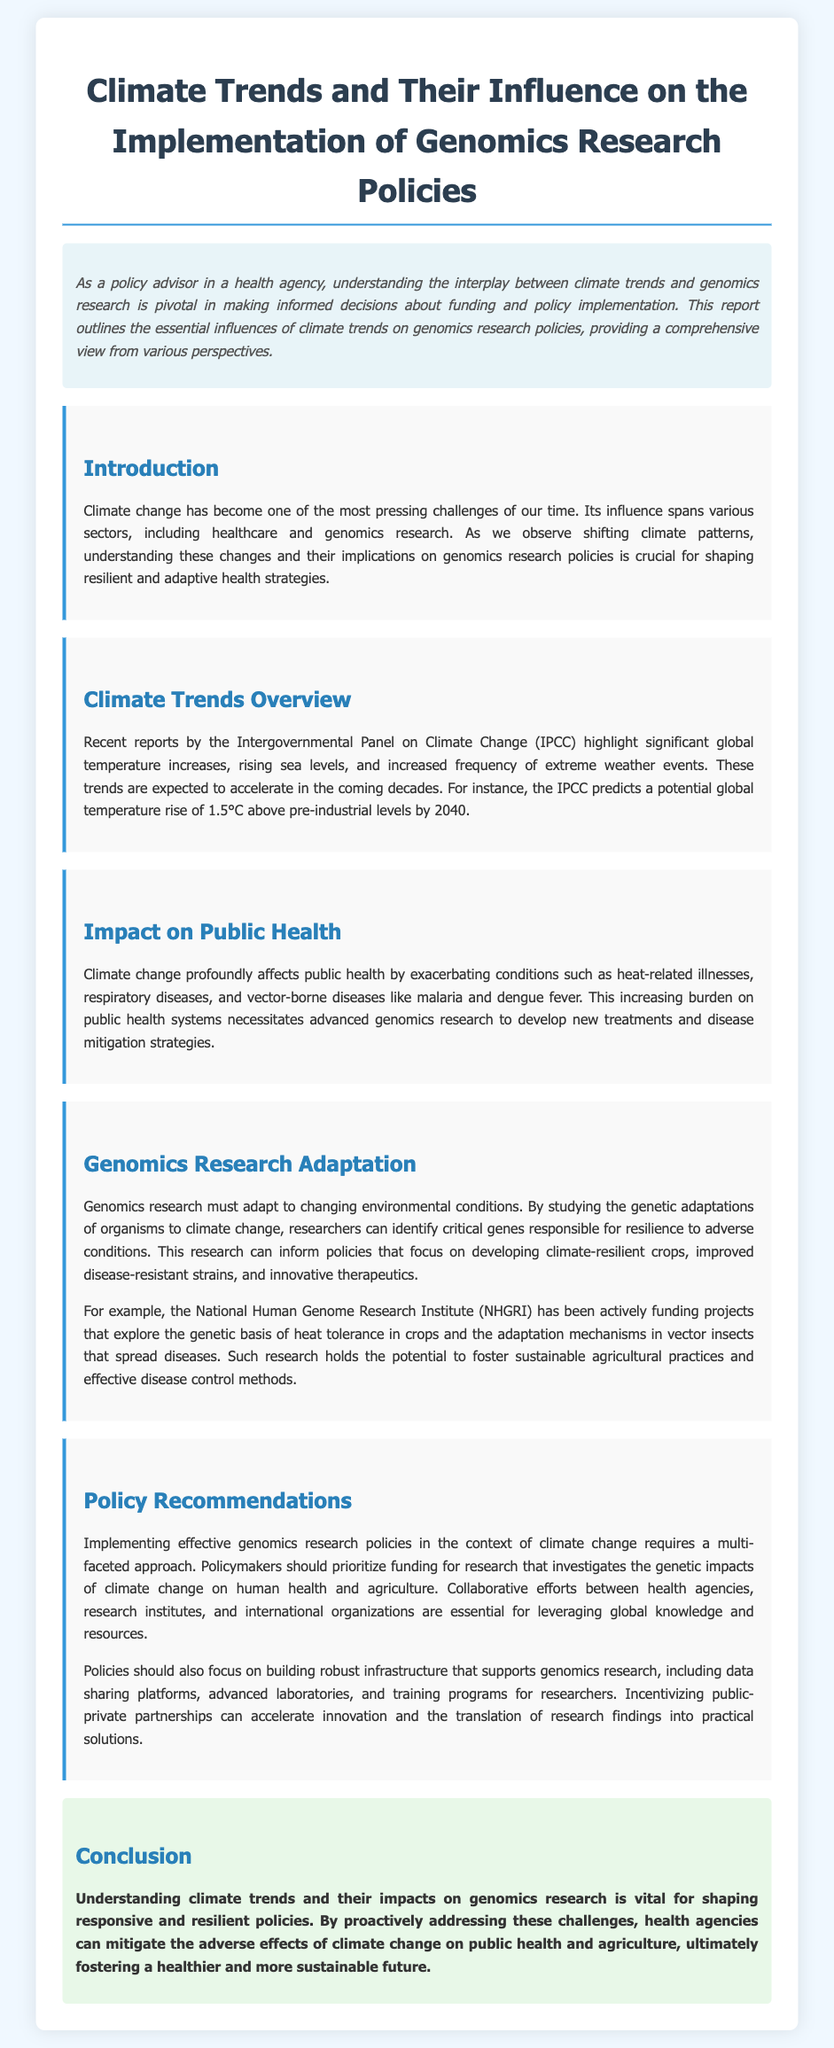What is the title of the report? The title of the report is prominently displayed at the top of the document.
Answer: Climate Trends and Their Influence on the Implementation of Genomics Research Policies What significant global temperature increase is predicted by 2040? The document states the specific temperature increase predicted by the IPCC for clarity.
Answer: 1.5°C What are two examples of diseases exacerbated by climate change mentioned in the report? The report lists the conditions affected by climate change, specifically mentioning diseases.
Answer: malaria and dengue fever Which institute is mentioned as funding projects related to heat tolerance in crops? The report refers to a specific institute involved in relevant research funding.
Answer: National Human Genome Research Institute (NHGRI) What is a recommended action for policymakers regarding genomics research? The document provides a suggestion for policymaking based on the findings discussed.
Answer: prioritize funding for research What does the report highlight as essential for effective genomics research policies? The document emphasizes the importance of specific collaborative mechanisms for policy implementation.
Answer: Collaborative efforts How do climate trends relate to genomics research, according to the report? The document discusses the interconnections between climate change and genomics research strategies.
Answer: critical genes responsible for resilience What is one of the identified burdens on public health due to climate change? The report outlines the effects of climate change on public health, highlighting significant consequences.
Answer: heat-related illnesses 